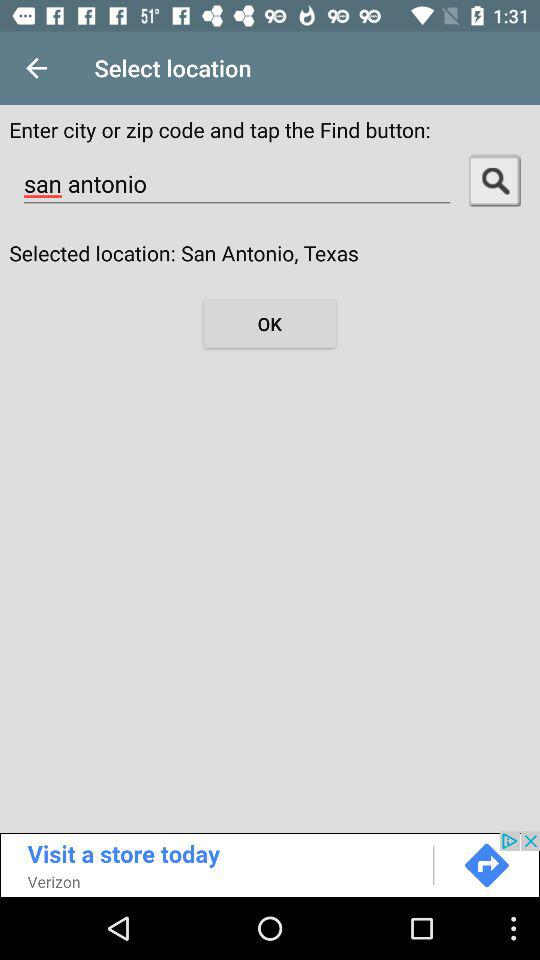What location is searched? The searched location is San Antonio. 